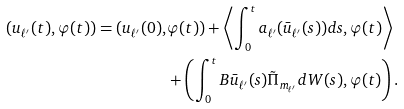<formula> <loc_0><loc_0><loc_500><loc_500>( u _ { \ell ^ { \prime } } ( t ) , \varphi ( t ) ) = ( u _ { \ell ^ { \prime } } ( 0 ) , & \varphi ( t ) ) + \left \langle \int _ { 0 } ^ { t } a _ { \ell ^ { \prime } } ( \bar { u } _ { \ell ^ { \prime } } ( s ) ) d s , \varphi ( t ) \right \rangle \\ & + \left ( \int _ { 0 } ^ { t } B \bar { u } _ { \ell ^ { \prime } } ( s ) \tilde { \Pi } _ { m _ { \ell ^ { \prime } } } d W ( s ) , \varphi ( t ) \right ) .</formula> 